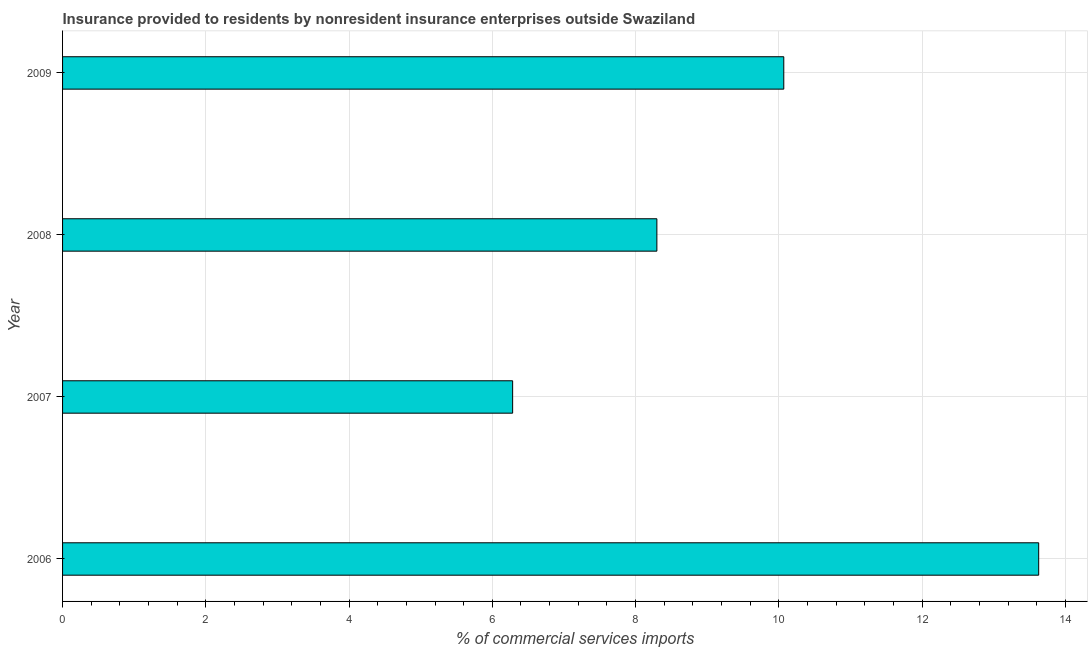Does the graph contain grids?
Offer a very short reply. Yes. What is the title of the graph?
Your answer should be compact. Insurance provided to residents by nonresident insurance enterprises outside Swaziland. What is the label or title of the X-axis?
Make the answer very short. % of commercial services imports. What is the label or title of the Y-axis?
Ensure brevity in your answer.  Year. What is the insurance provided by non-residents in 2006?
Your answer should be very brief. 13.63. Across all years, what is the maximum insurance provided by non-residents?
Your answer should be compact. 13.63. Across all years, what is the minimum insurance provided by non-residents?
Your response must be concise. 6.28. In which year was the insurance provided by non-residents maximum?
Keep it short and to the point. 2006. In which year was the insurance provided by non-residents minimum?
Keep it short and to the point. 2007. What is the sum of the insurance provided by non-residents?
Offer a very short reply. 38.28. What is the difference between the insurance provided by non-residents in 2006 and 2007?
Provide a short and direct response. 7.34. What is the average insurance provided by non-residents per year?
Provide a succinct answer. 9.57. What is the median insurance provided by non-residents?
Provide a short and direct response. 9.18. In how many years, is the insurance provided by non-residents greater than 10 %?
Provide a short and direct response. 2. Do a majority of the years between 2009 and 2006 (inclusive) have insurance provided by non-residents greater than 0.8 %?
Ensure brevity in your answer.  Yes. What is the ratio of the insurance provided by non-residents in 2006 to that in 2007?
Offer a terse response. 2.17. Is the difference between the insurance provided by non-residents in 2006 and 2007 greater than the difference between any two years?
Your answer should be compact. Yes. What is the difference between the highest and the second highest insurance provided by non-residents?
Give a very brief answer. 3.56. Is the sum of the insurance provided by non-residents in 2006 and 2008 greater than the maximum insurance provided by non-residents across all years?
Provide a short and direct response. Yes. What is the difference between the highest and the lowest insurance provided by non-residents?
Offer a terse response. 7.34. In how many years, is the insurance provided by non-residents greater than the average insurance provided by non-residents taken over all years?
Give a very brief answer. 2. How many years are there in the graph?
Your answer should be very brief. 4. What is the % of commercial services imports in 2006?
Ensure brevity in your answer.  13.63. What is the % of commercial services imports of 2007?
Your response must be concise. 6.28. What is the % of commercial services imports in 2008?
Provide a succinct answer. 8.3. What is the % of commercial services imports in 2009?
Provide a succinct answer. 10.07. What is the difference between the % of commercial services imports in 2006 and 2007?
Ensure brevity in your answer.  7.34. What is the difference between the % of commercial services imports in 2006 and 2008?
Your answer should be very brief. 5.33. What is the difference between the % of commercial services imports in 2006 and 2009?
Your answer should be compact. 3.56. What is the difference between the % of commercial services imports in 2007 and 2008?
Ensure brevity in your answer.  -2.01. What is the difference between the % of commercial services imports in 2007 and 2009?
Provide a short and direct response. -3.79. What is the difference between the % of commercial services imports in 2008 and 2009?
Offer a terse response. -1.77. What is the ratio of the % of commercial services imports in 2006 to that in 2007?
Offer a very short reply. 2.17. What is the ratio of the % of commercial services imports in 2006 to that in 2008?
Your response must be concise. 1.64. What is the ratio of the % of commercial services imports in 2006 to that in 2009?
Provide a short and direct response. 1.35. What is the ratio of the % of commercial services imports in 2007 to that in 2008?
Make the answer very short. 0.76. What is the ratio of the % of commercial services imports in 2007 to that in 2009?
Ensure brevity in your answer.  0.62. What is the ratio of the % of commercial services imports in 2008 to that in 2009?
Provide a succinct answer. 0.82. 